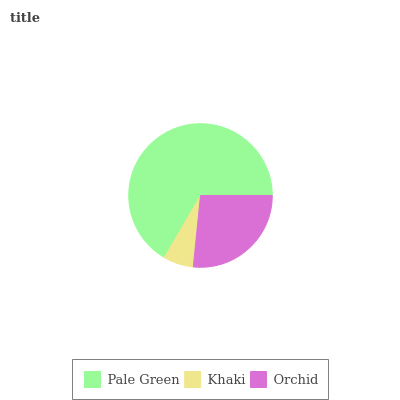Is Khaki the minimum?
Answer yes or no. Yes. Is Pale Green the maximum?
Answer yes or no. Yes. Is Orchid the minimum?
Answer yes or no. No. Is Orchid the maximum?
Answer yes or no. No. Is Orchid greater than Khaki?
Answer yes or no. Yes. Is Khaki less than Orchid?
Answer yes or no. Yes. Is Khaki greater than Orchid?
Answer yes or no. No. Is Orchid less than Khaki?
Answer yes or no. No. Is Orchid the high median?
Answer yes or no. Yes. Is Orchid the low median?
Answer yes or no. Yes. Is Khaki the high median?
Answer yes or no. No. Is Khaki the low median?
Answer yes or no. No. 